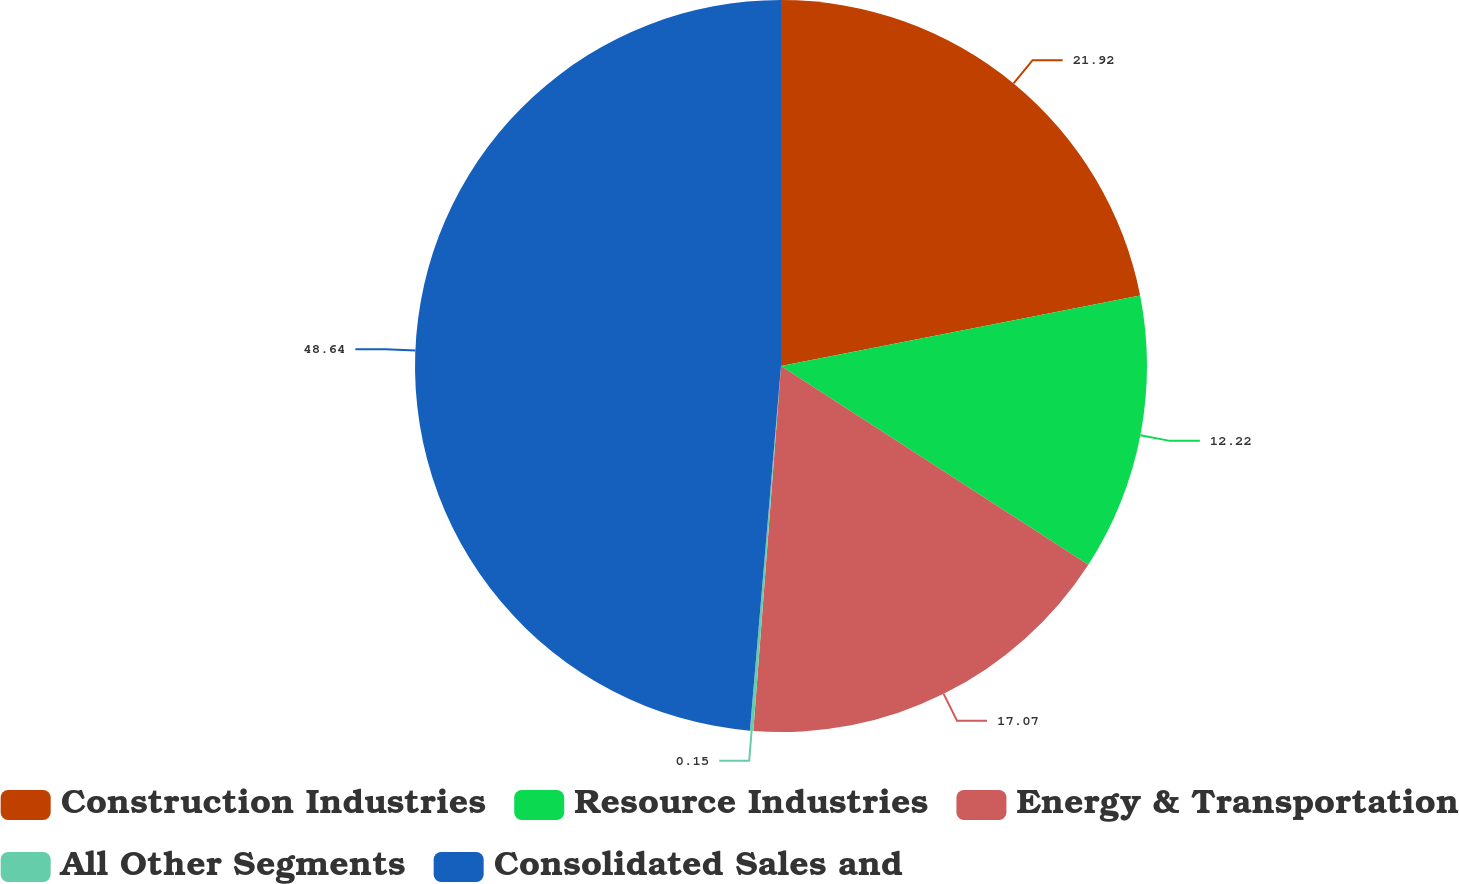Convert chart to OTSL. <chart><loc_0><loc_0><loc_500><loc_500><pie_chart><fcel>Construction Industries<fcel>Resource Industries<fcel>Energy & Transportation<fcel>All Other Segments<fcel>Consolidated Sales and<nl><fcel>21.92%<fcel>12.22%<fcel>17.07%<fcel>0.15%<fcel>48.65%<nl></chart> 